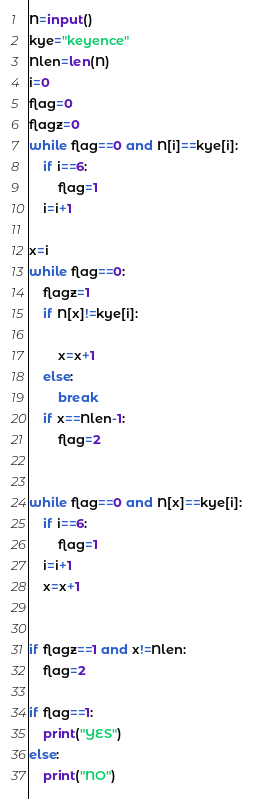Convert code to text. <code><loc_0><loc_0><loc_500><loc_500><_Python_>N=input()
kye="keyence"
Nlen=len(N)
i=0
flag=0
flagz=0
while flag==0 and N[i]==kye[i]:
    if i==6:
        flag=1
    i=i+1

x=i
while flag==0:
    flagz=1
    if N[x]!=kye[i]:
        
        x=x+1
    else:
        break
    if x==Nlen-1:
        flag=2
    

while flag==0 and N[x]==kye[i]:
    if i==6:
        flag=1
    i=i+1
    x=x+1


if flagz==1 and x!=Nlen:
    flag=2

if flag==1:
    print("YES")
else:
    print("NO")</code> 